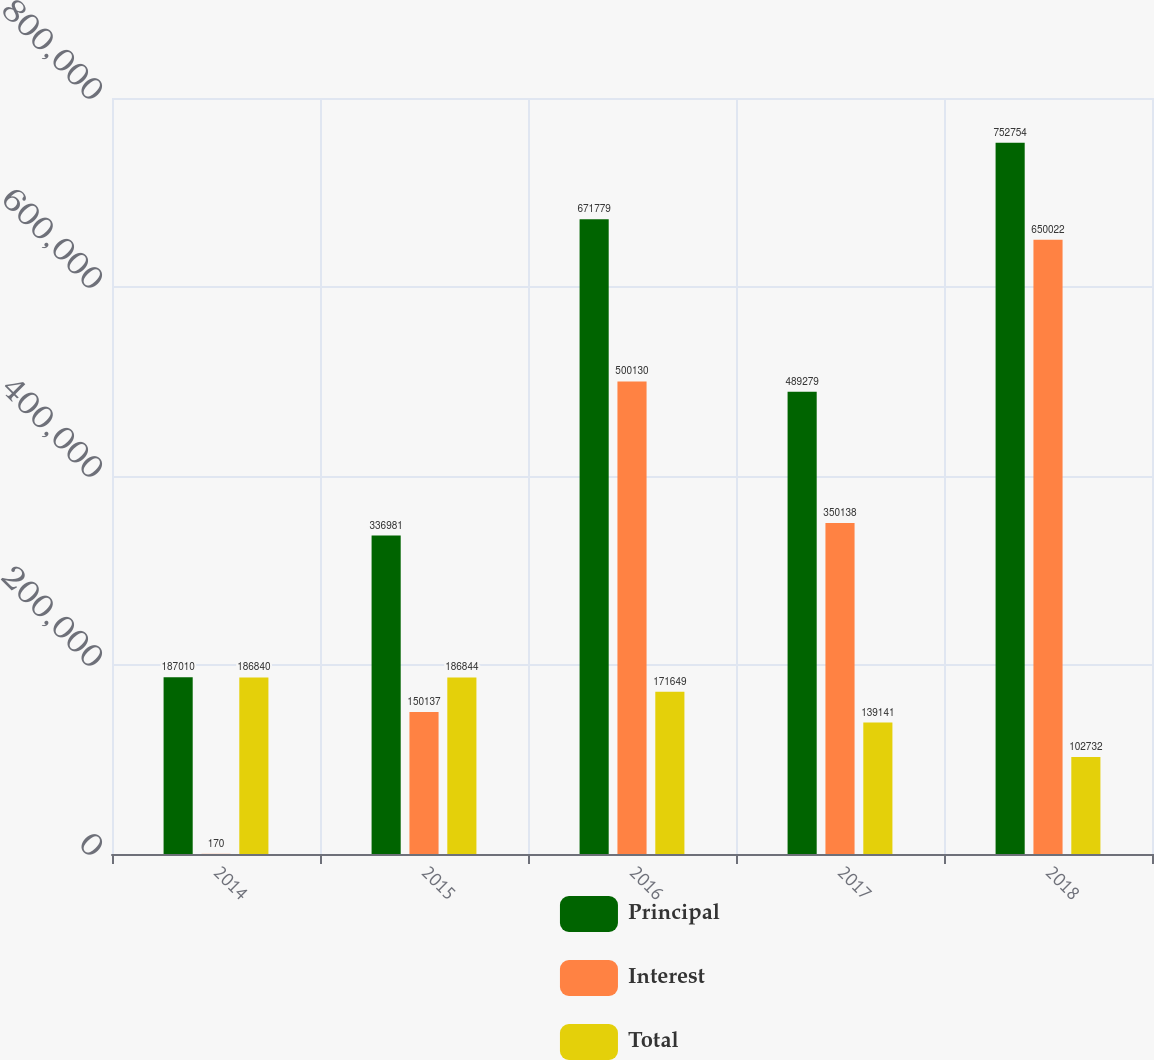Convert chart. <chart><loc_0><loc_0><loc_500><loc_500><stacked_bar_chart><ecel><fcel>2014<fcel>2015<fcel>2016<fcel>2017<fcel>2018<nl><fcel>Principal<fcel>187010<fcel>336981<fcel>671779<fcel>489279<fcel>752754<nl><fcel>Interest<fcel>170<fcel>150137<fcel>500130<fcel>350138<fcel>650022<nl><fcel>Total<fcel>186840<fcel>186844<fcel>171649<fcel>139141<fcel>102732<nl></chart> 